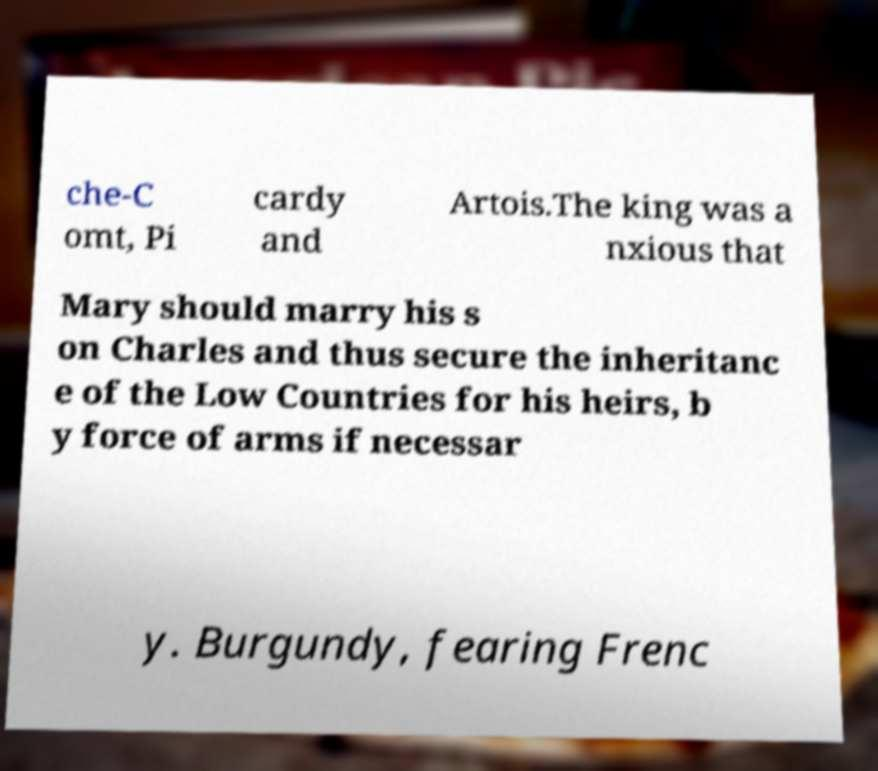What messages or text are displayed in this image? I need them in a readable, typed format. che-C omt, Pi cardy and Artois.The king was a nxious that Mary should marry his s on Charles and thus secure the inheritanc e of the Low Countries for his heirs, b y force of arms if necessar y. Burgundy, fearing Frenc 